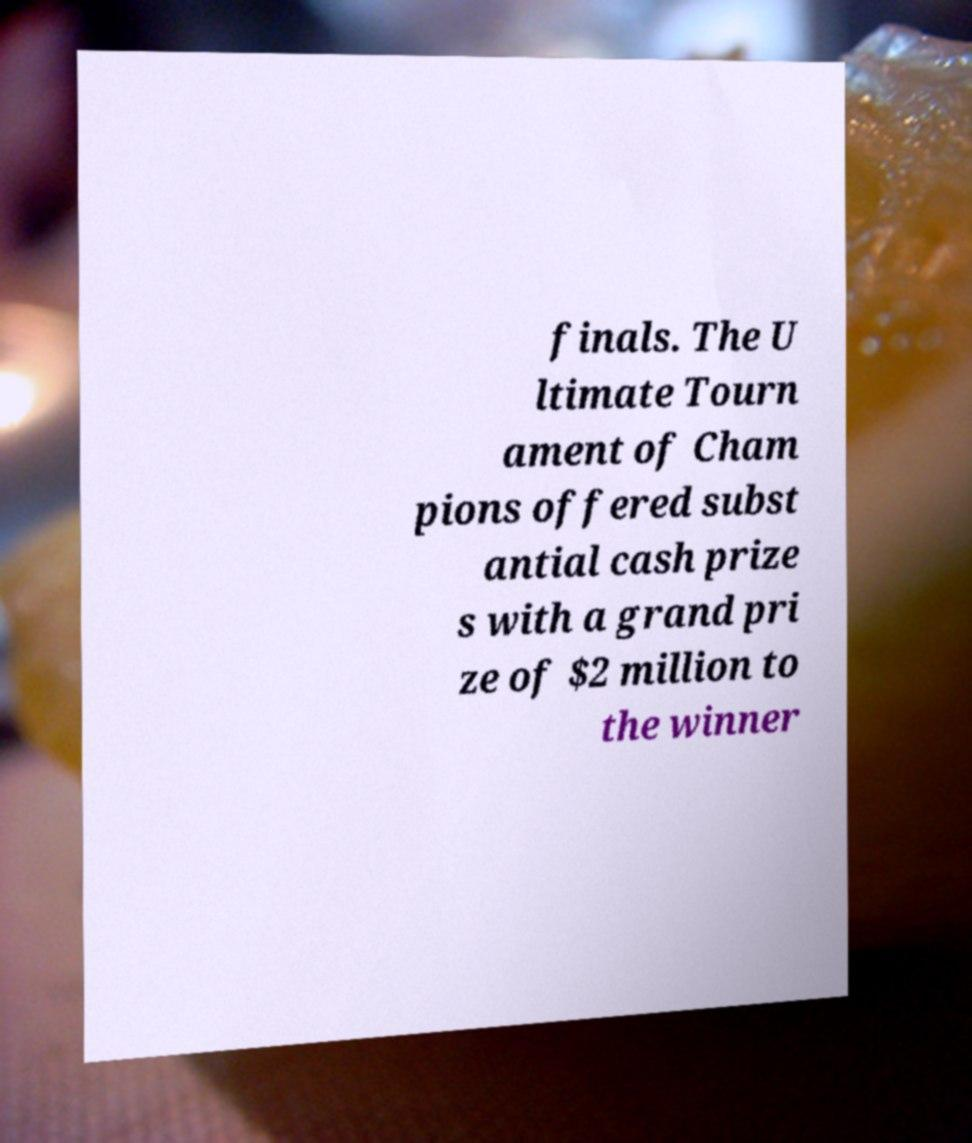Can you accurately transcribe the text from the provided image for me? finals. The U ltimate Tourn ament of Cham pions offered subst antial cash prize s with a grand pri ze of $2 million to the winner 